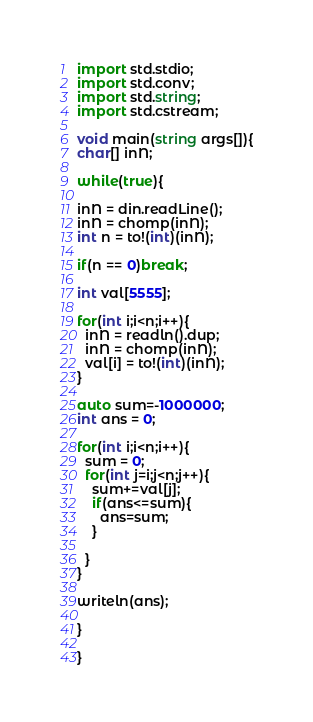<code> <loc_0><loc_0><loc_500><loc_500><_D_>import std.stdio;
import std.conv;
import std.string;
import std.cstream;

void main(string args[]){
char[] inN;

while(true){

inN = din.readLine();
inN = chomp(inN);
int n = to!(int)(inN);

if(n == 0)break;

int val[5555];

for(int i;i<n;i++){
  inN = readln().dup;
  inN = chomp(inN);
  val[i] = to!(int)(inN);
}

auto sum=-1000000;
int ans = 0;

for(int i;i<n;i++){
  sum = 0;
  for(int j=i;j<n;j++){
    sum+=val[j];
    if(ans<=sum){
      ans=sum;
    }

  }
}

writeln(ans);

}

}</code> 